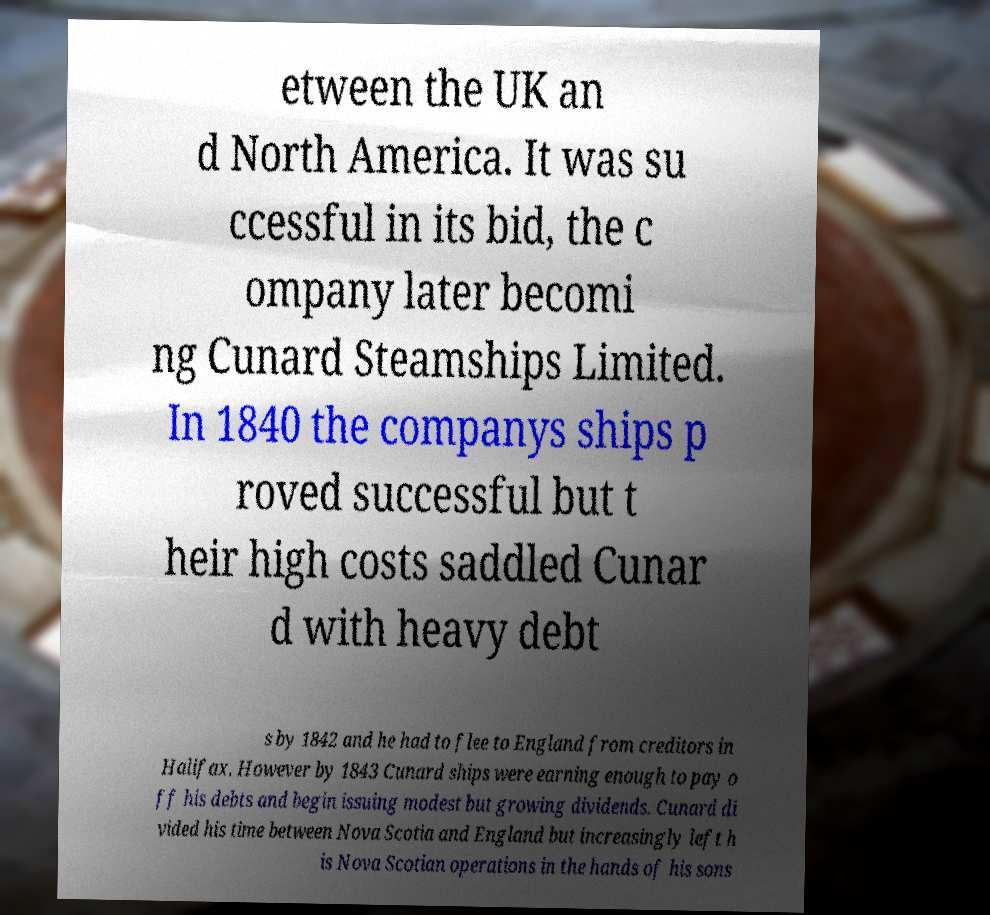For documentation purposes, I need the text within this image transcribed. Could you provide that? etween the UK an d North America. It was su ccessful in its bid, the c ompany later becomi ng Cunard Steamships Limited. In 1840 the companys ships p roved successful but t heir high costs saddled Cunar d with heavy debt s by 1842 and he had to flee to England from creditors in Halifax. However by 1843 Cunard ships were earning enough to pay o ff his debts and begin issuing modest but growing dividends. Cunard di vided his time between Nova Scotia and England but increasingly left h is Nova Scotian operations in the hands of his sons 